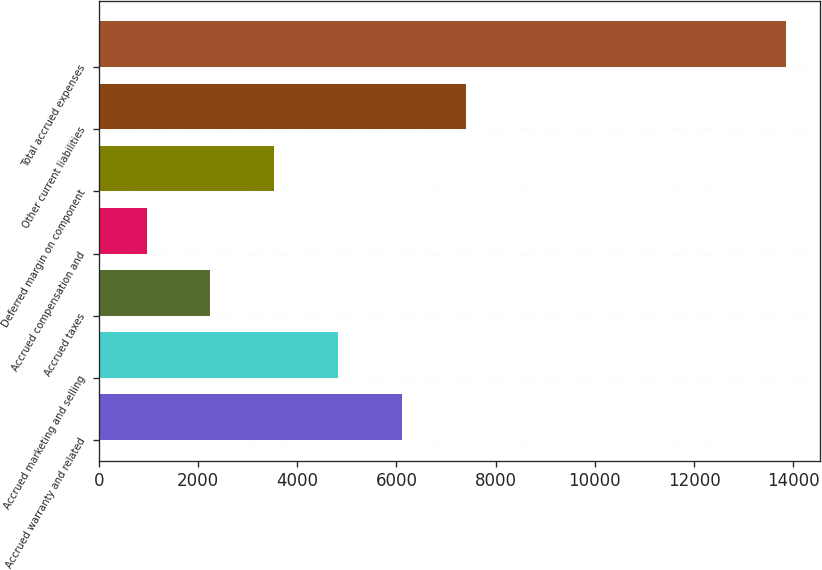<chart> <loc_0><loc_0><loc_500><loc_500><bar_chart><fcel>Accrued warranty and related<fcel>Accrued marketing and selling<fcel>Accrued taxes<fcel>Accrued compensation and<fcel>Deferred margin on component<fcel>Other current liabilities<fcel>Total accrued expenses<nl><fcel>6117.8<fcel>4828.1<fcel>2248.7<fcel>959<fcel>3538.4<fcel>7407.5<fcel>13856<nl></chart> 